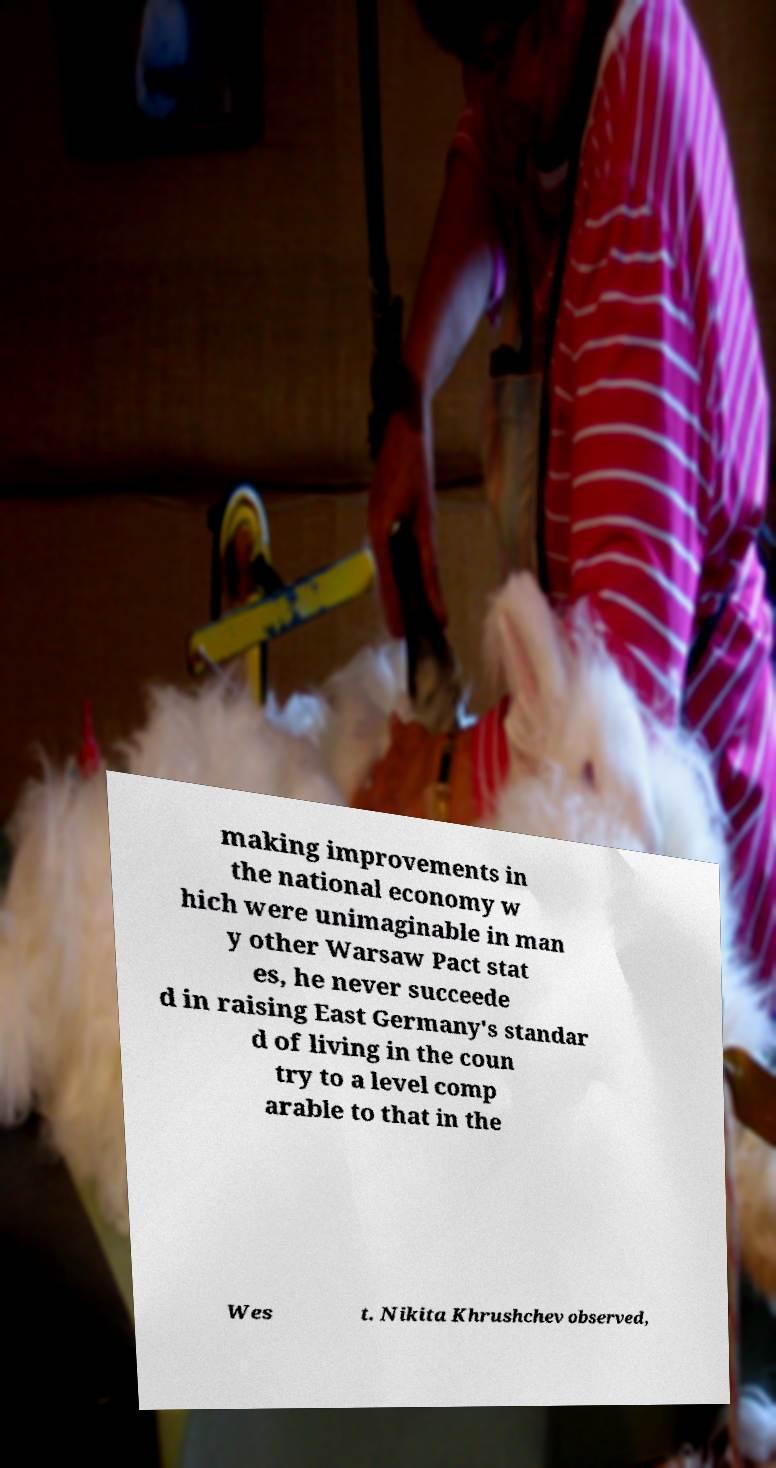Could you assist in decoding the text presented in this image and type it out clearly? making improvements in the national economy w hich were unimaginable in man y other Warsaw Pact stat es, he never succeede d in raising East Germany's standar d of living in the coun try to a level comp arable to that in the Wes t. Nikita Khrushchev observed, 